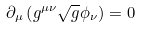Convert formula to latex. <formula><loc_0><loc_0><loc_500><loc_500>\partial _ { \mu } \left ( g ^ { \mu \nu } \sqrt { g } \phi _ { \nu } \right ) = 0</formula> 